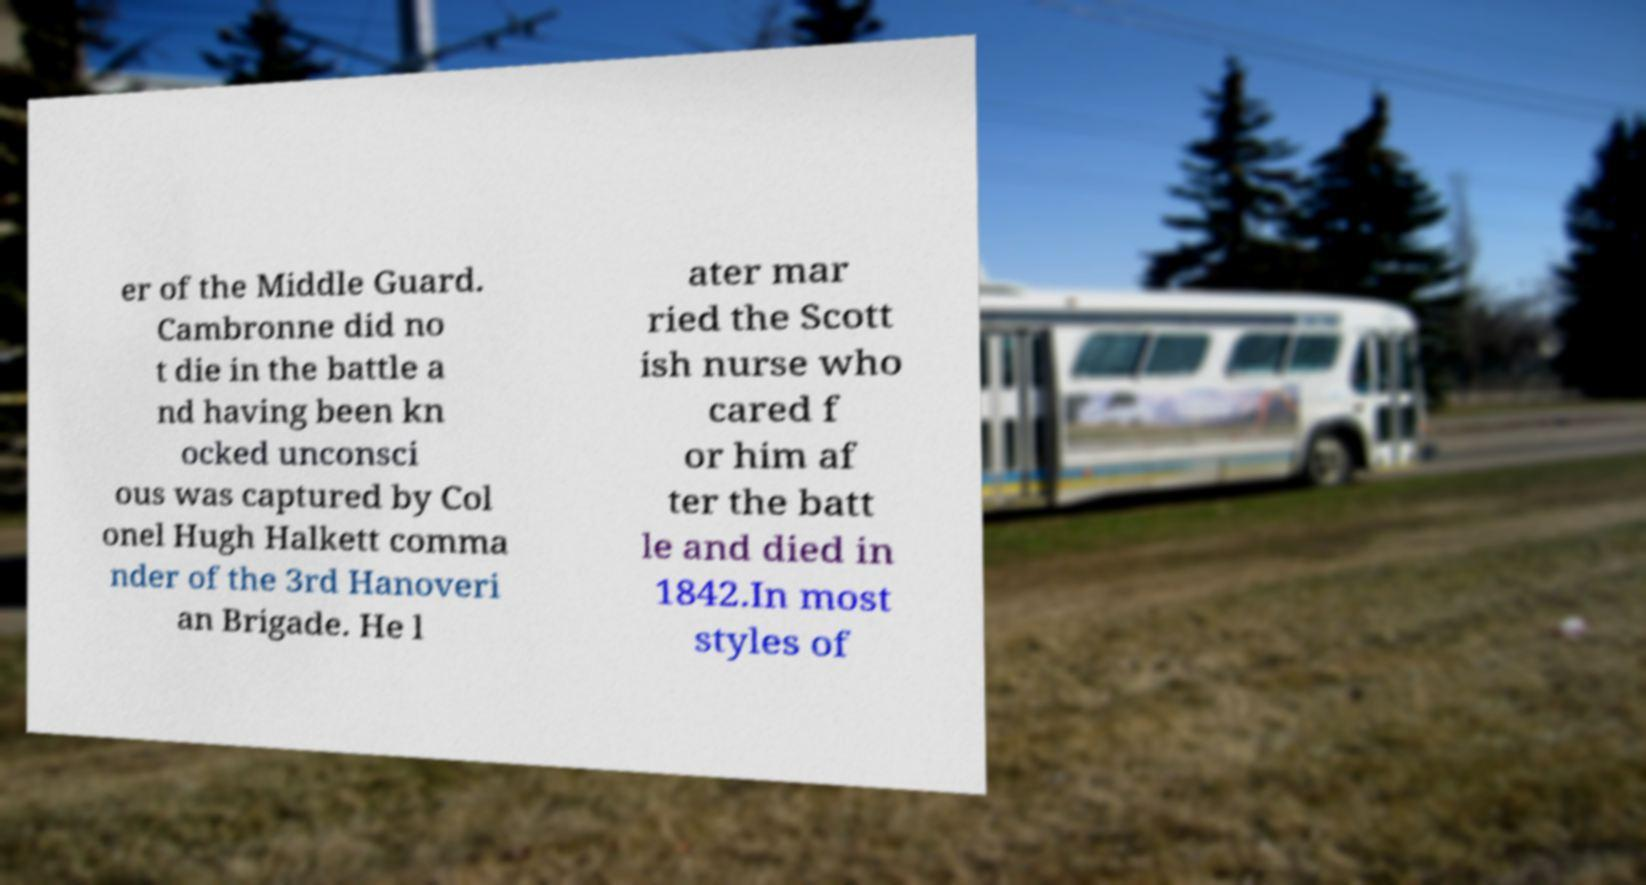Could you assist in decoding the text presented in this image and type it out clearly? er of the Middle Guard. Cambronne did no t die in the battle a nd having been kn ocked unconsci ous was captured by Col onel Hugh Halkett comma nder of the 3rd Hanoveri an Brigade. He l ater mar ried the Scott ish nurse who cared f or him af ter the batt le and died in 1842.In most styles of 